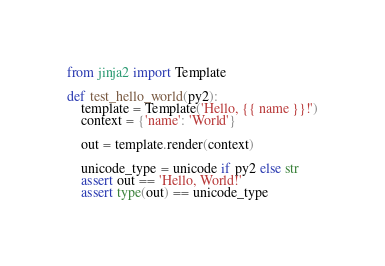Convert code to text. <code><loc_0><loc_0><loc_500><loc_500><_Python_>from jinja2 import Template

def test_hello_world(py2):
    template = Template('Hello, {{ name }}!')
    context = {'name': 'World'}

    out = template.render(context)

    unicode_type = unicode if py2 else str
    assert out == 'Hello, World!'
    assert type(out) == unicode_type</code> 